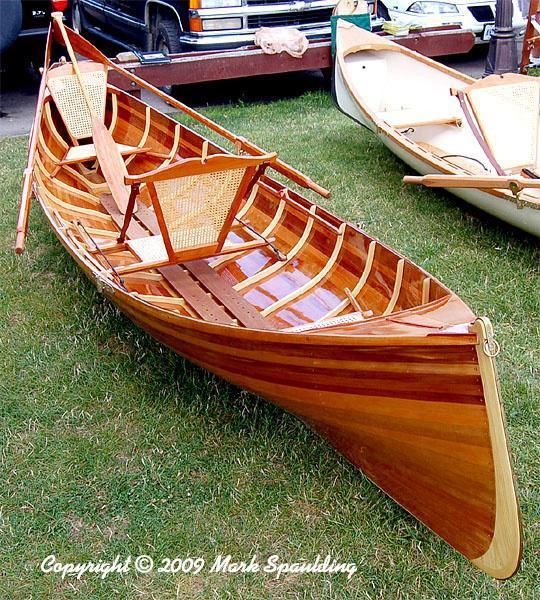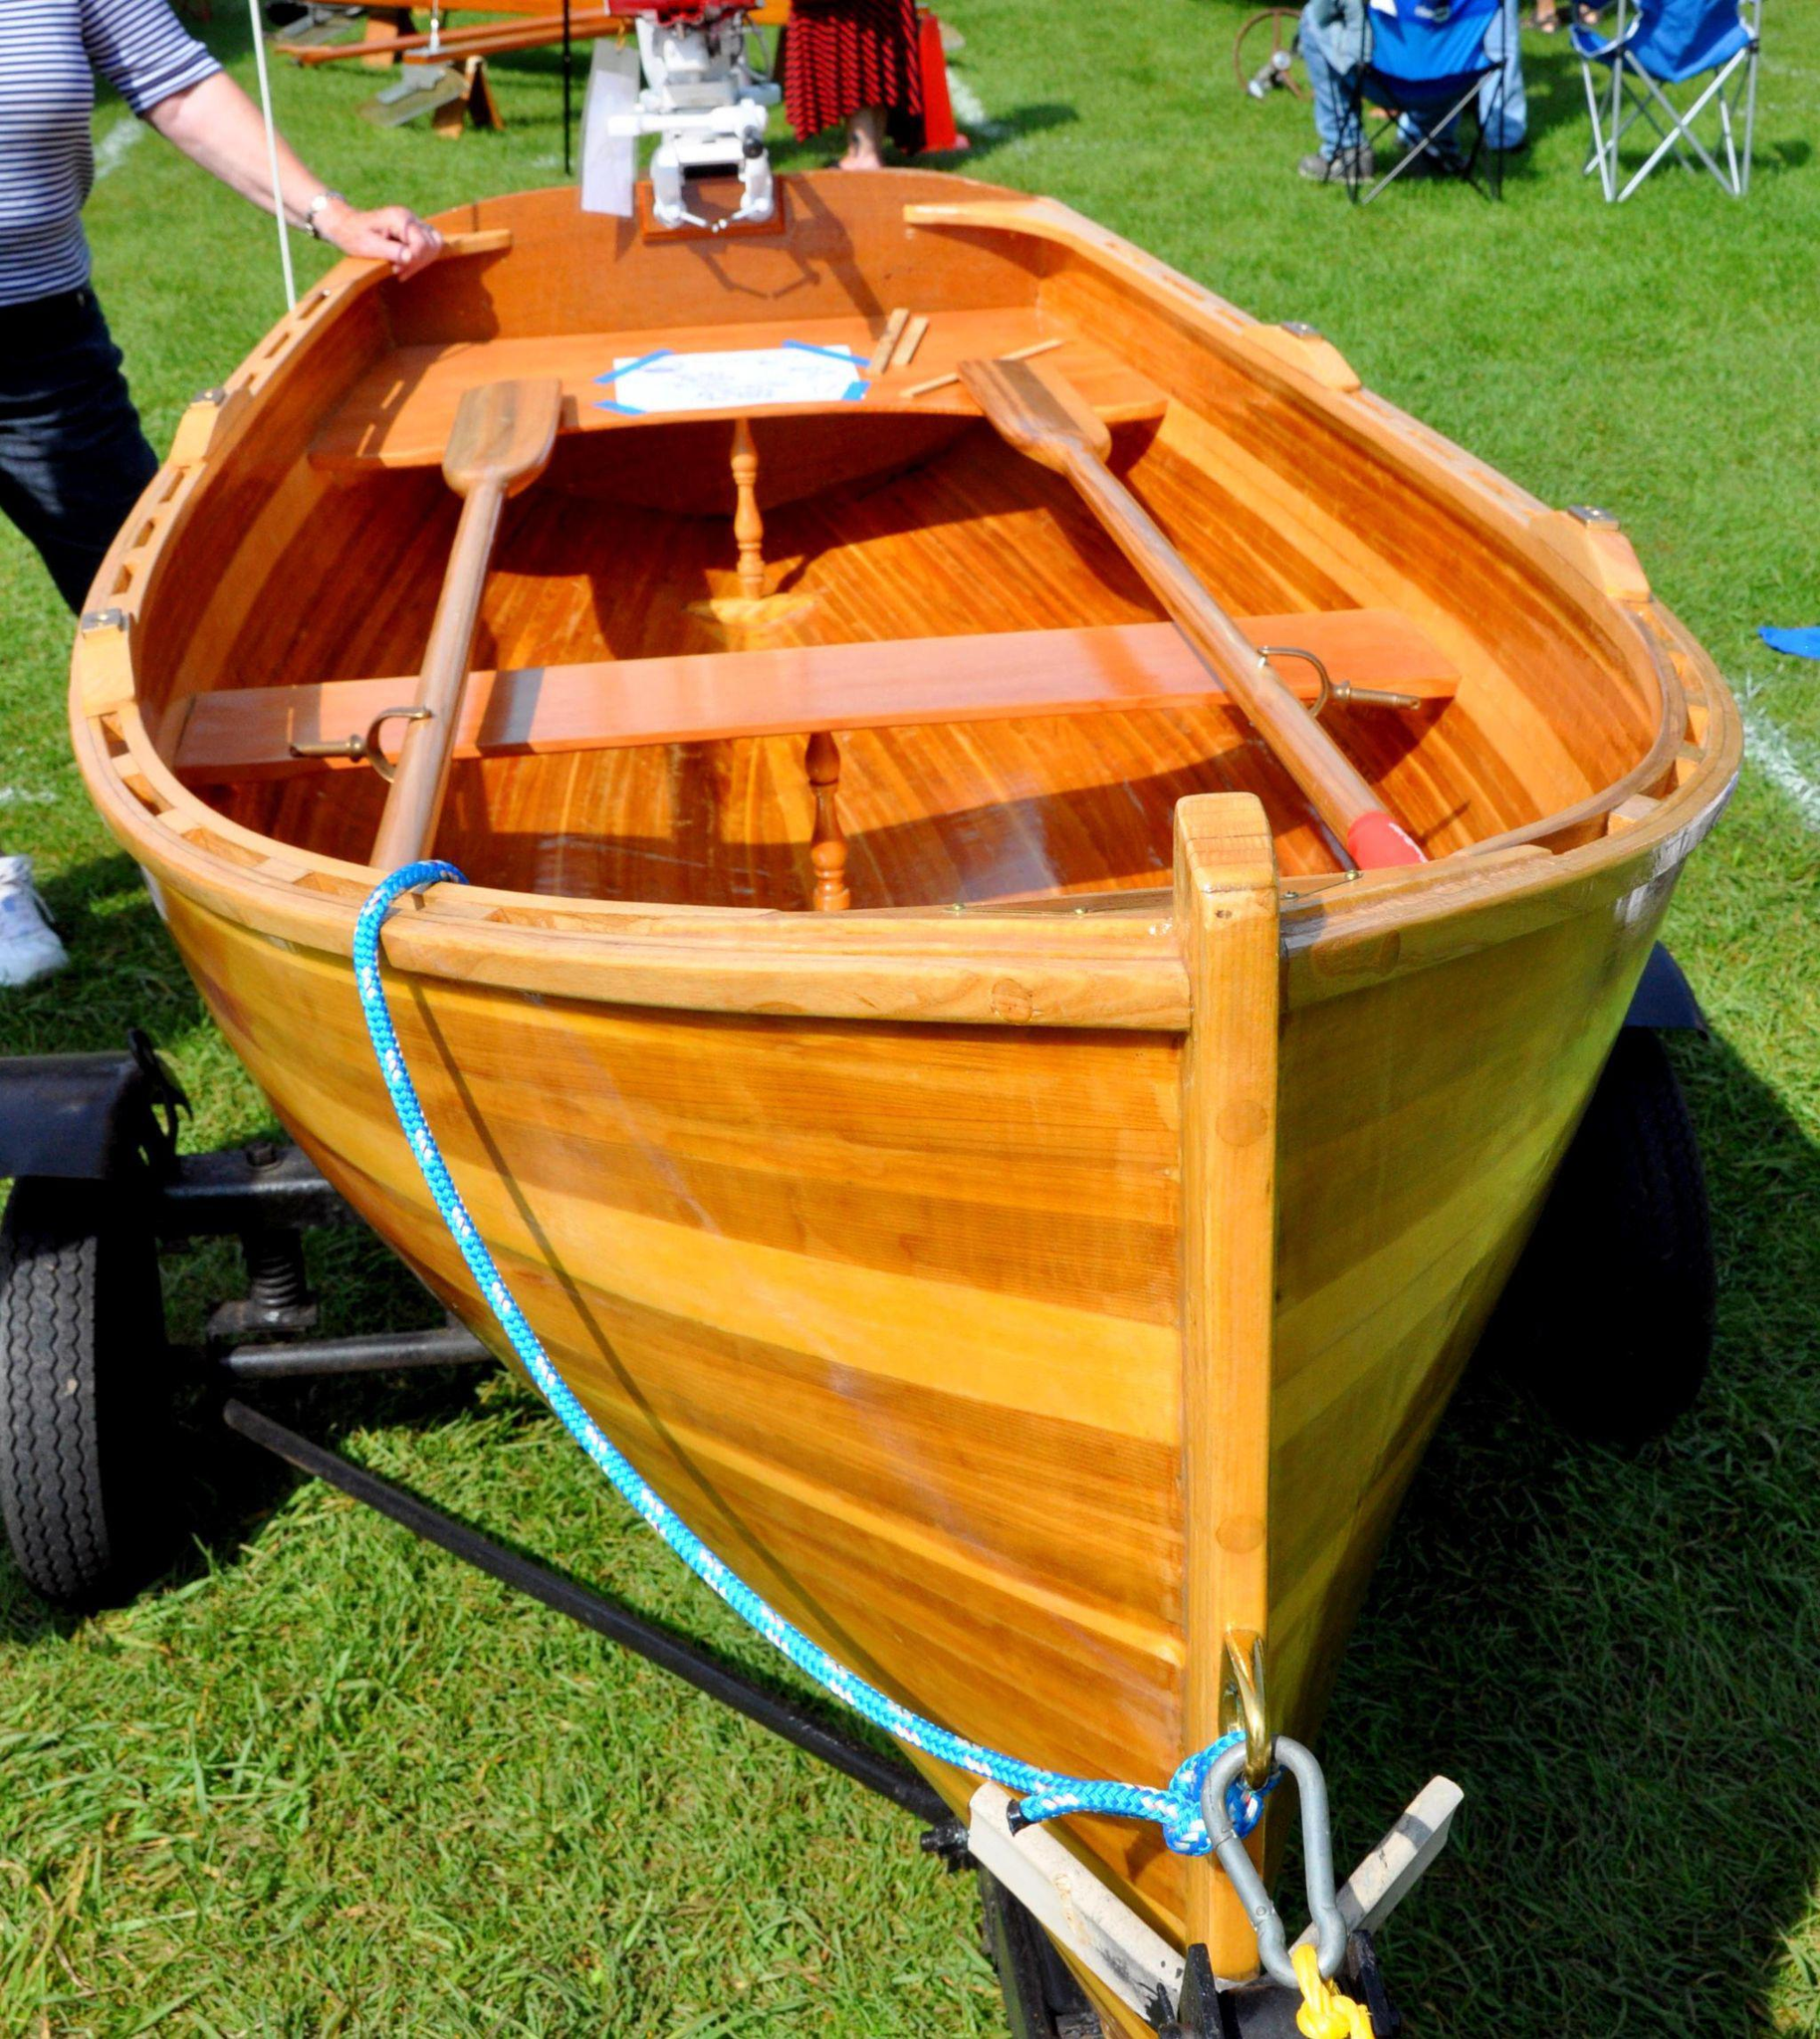The first image is the image on the left, the second image is the image on the right. Evaluate the accuracy of this statement regarding the images: "Each image shows a single prominent wooden boat, and the boats in the left and right images face the same general direction.". Is it true? Answer yes or no. Yes. The first image is the image on the left, the second image is the image on the right. Assess this claim about the two images: "There are more than two boats visible.". Correct or not? Answer yes or no. Yes. 